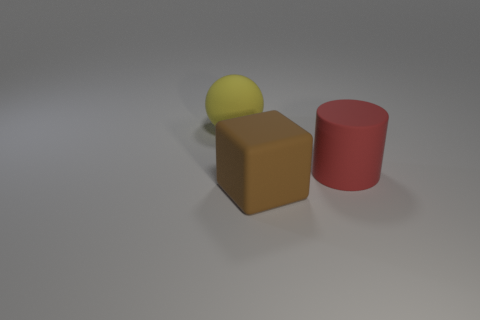Is the size of the rubber block the same as the red cylinder?
Ensure brevity in your answer.  Yes. What number of other objects are the same size as the brown rubber block?
Your response must be concise. 2. How many things are big matte objects that are on the right side of the big yellow sphere or red objects that are in front of the yellow rubber thing?
Keep it short and to the point. 2. The yellow rubber object that is the same size as the red cylinder is what shape?
Your answer should be compact. Sphere. There is a block that is the same size as the red thing; what color is it?
Provide a succinct answer. Brown. The big rubber object that is in front of the red matte thing has what shape?
Ensure brevity in your answer.  Cube. Do the large brown matte object and the thing that is behind the large red rubber object have the same shape?
Offer a very short reply. No. Are there the same number of big balls in front of the brown matte cube and red matte cylinders that are on the left side of the big red cylinder?
Ensure brevity in your answer.  Yes. There is a big matte object that is on the left side of the large rubber block; is its color the same as the rubber object that is on the right side of the brown rubber cube?
Ensure brevity in your answer.  No. Are there more red rubber cylinders that are to the left of the large cube than big balls?
Keep it short and to the point. No. 